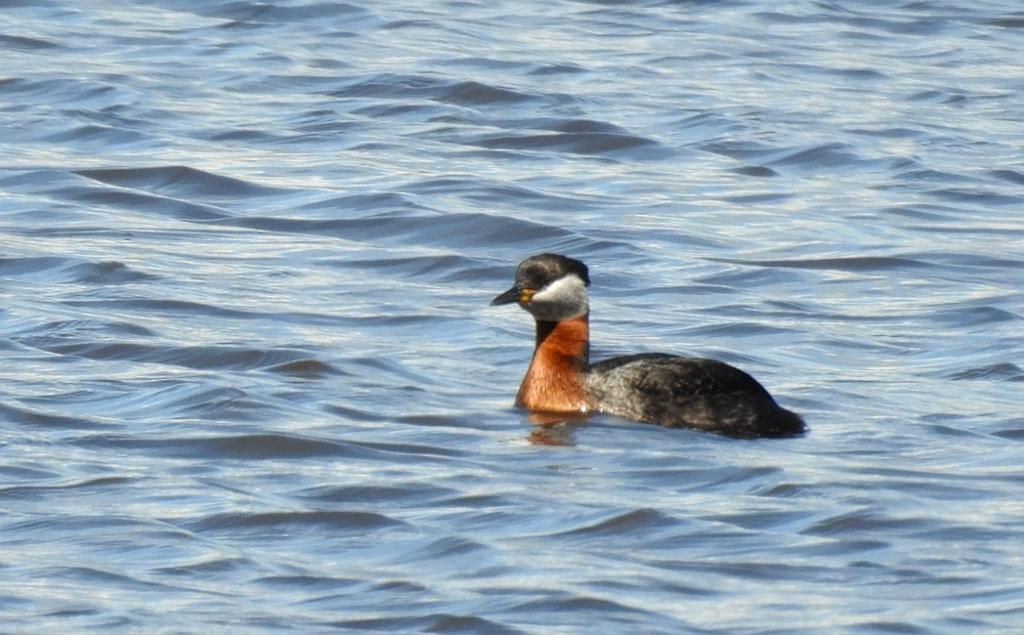What animal is present in the image? There is a duck in the image. Where is the duck located? The duck is in the water. What type of sofa does the queen sit on in the image? There is no queen or sofa present in the image; it features a duck in the water. 